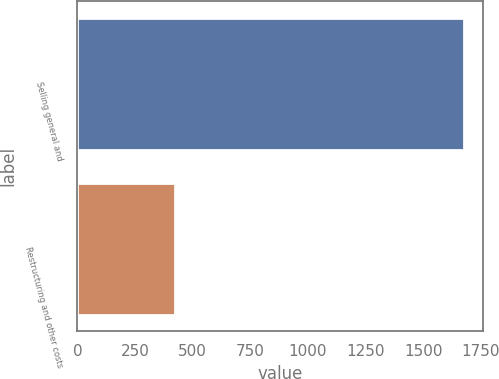Convert chart. <chart><loc_0><loc_0><loc_500><loc_500><bar_chart><fcel>Selling general and<fcel>Restructuring and other costs<nl><fcel>1674.7<fcel>425.2<nl></chart> 